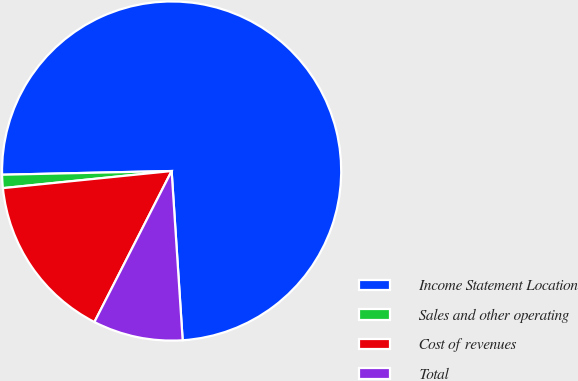Convert chart to OTSL. <chart><loc_0><loc_0><loc_500><loc_500><pie_chart><fcel>Income Statement Location<fcel>Sales and other operating<fcel>Cost of revenues<fcel>Total<nl><fcel>74.31%<fcel>1.26%<fcel>15.87%<fcel>8.56%<nl></chart> 